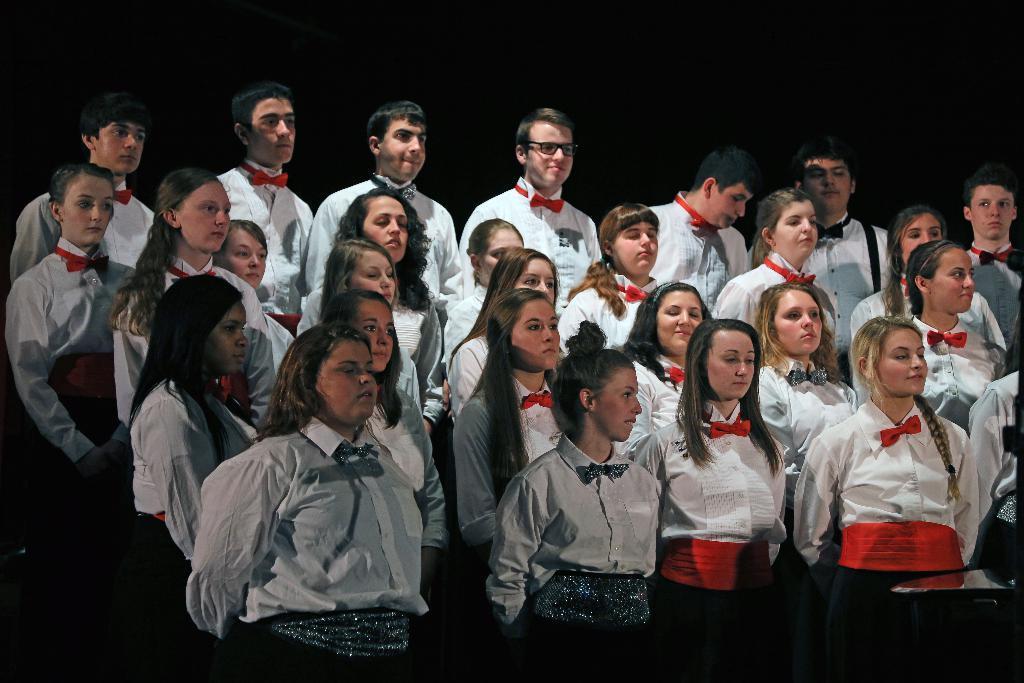In one or two sentences, can you explain what this image depicts? In this image we can see a group of people standing and wearing same color dress and the background is dark. 